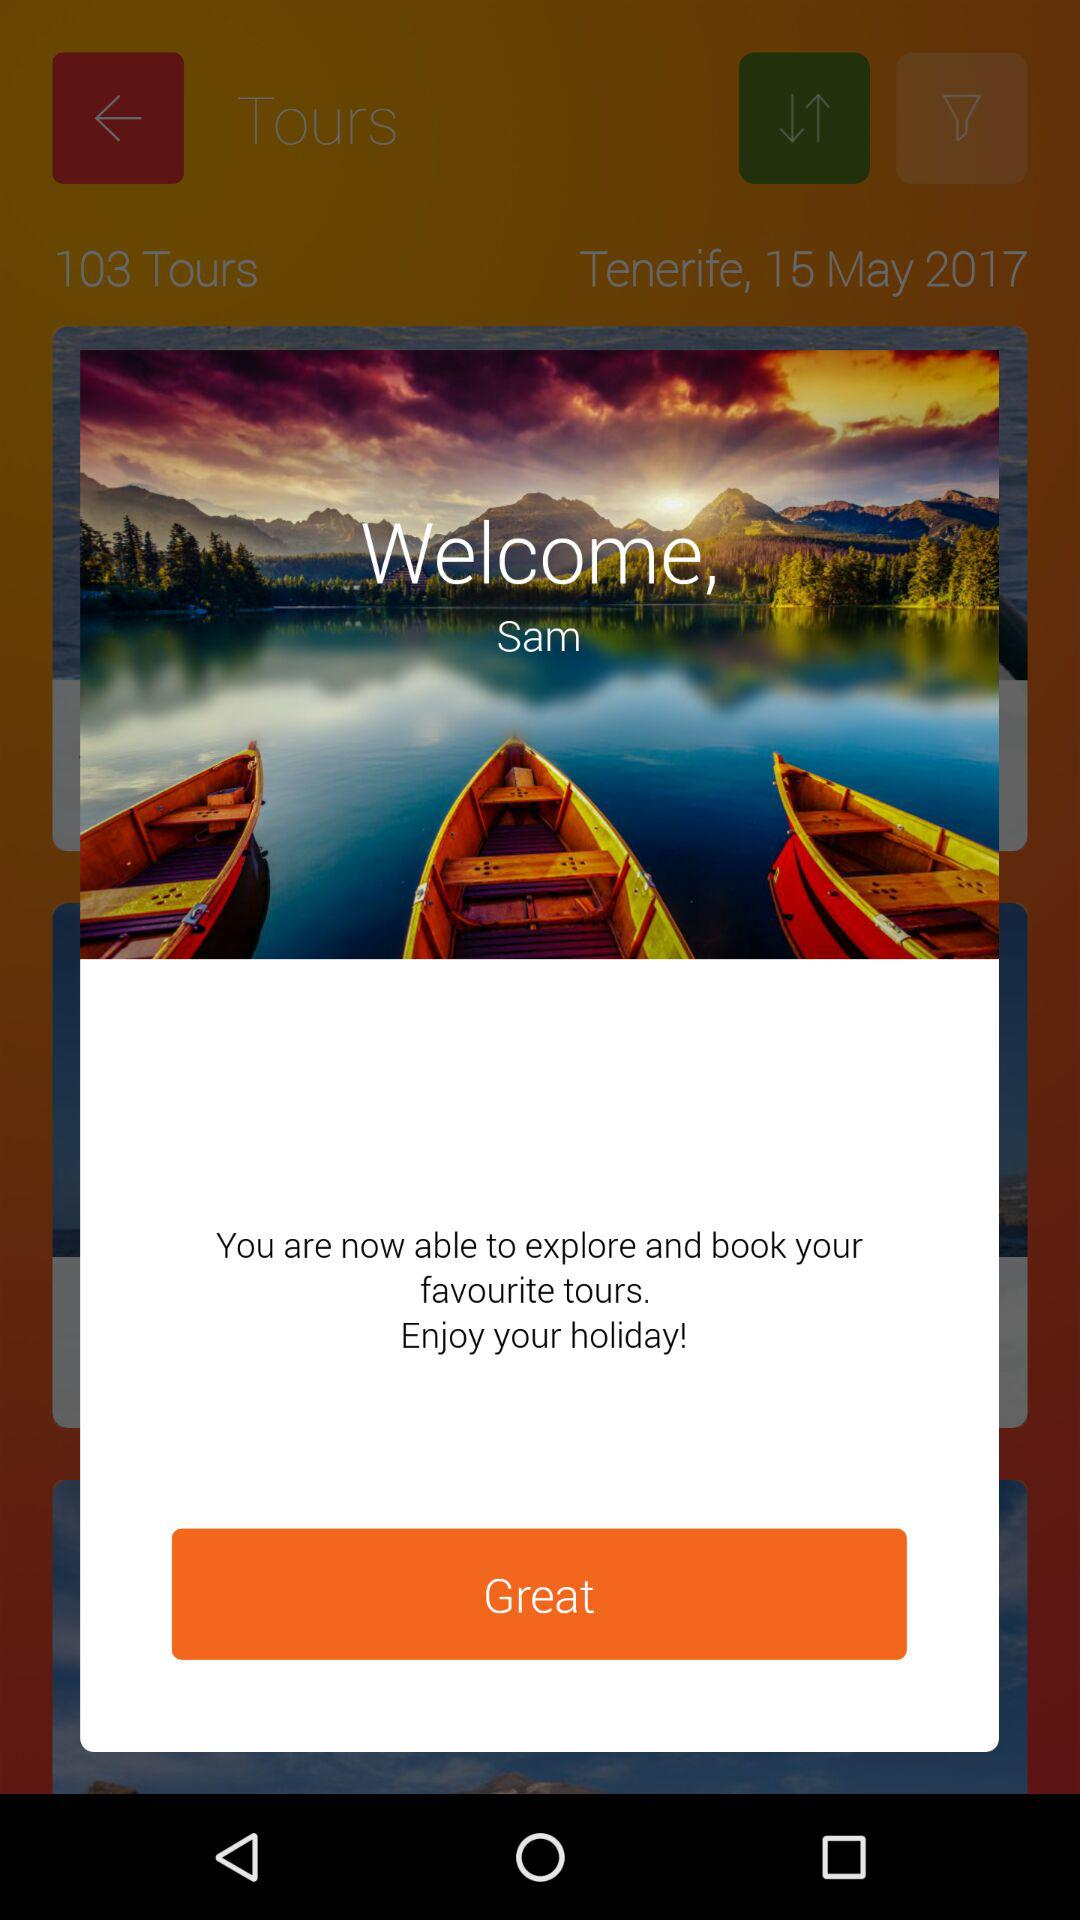What is the location of the tour? The location is Tenerife. 